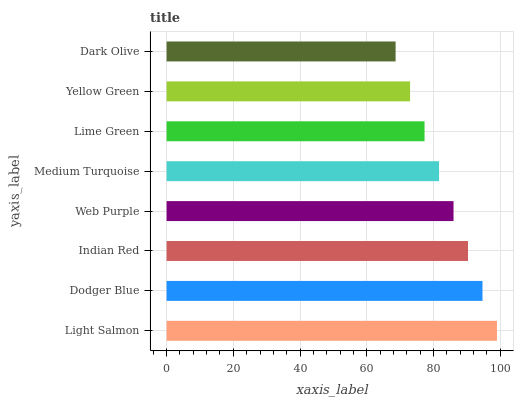Is Dark Olive the minimum?
Answer yes or no. Yes. Is Light Salmon the maximum?
Answer yes or no. Yes. Is Dodger Blue the minimum?
Answer yes or no. No. Is Dodger Blue the maximum?
Answer yes or no. No. Is Light Salmon greater than Dodger Blue?
Answer yes or no. Yes. Is Dodger Blue less than Light Salmon?
Answer yes or no. Yes. Is Dodger Blue greater than Light Salmon?
Answer yes or no. No. Is Light Salmon less than Dodger Blue?
Answer yes or no. No. Is Web Purple the high median?
Answer yes or no. Yes. Is Medium Turquoise the low median?
Answer yes or no. Yes. Is Yellow Green the high median?
Answer yes or no. No. Is Light Salmon the low median?
Answer yes or no. No. 